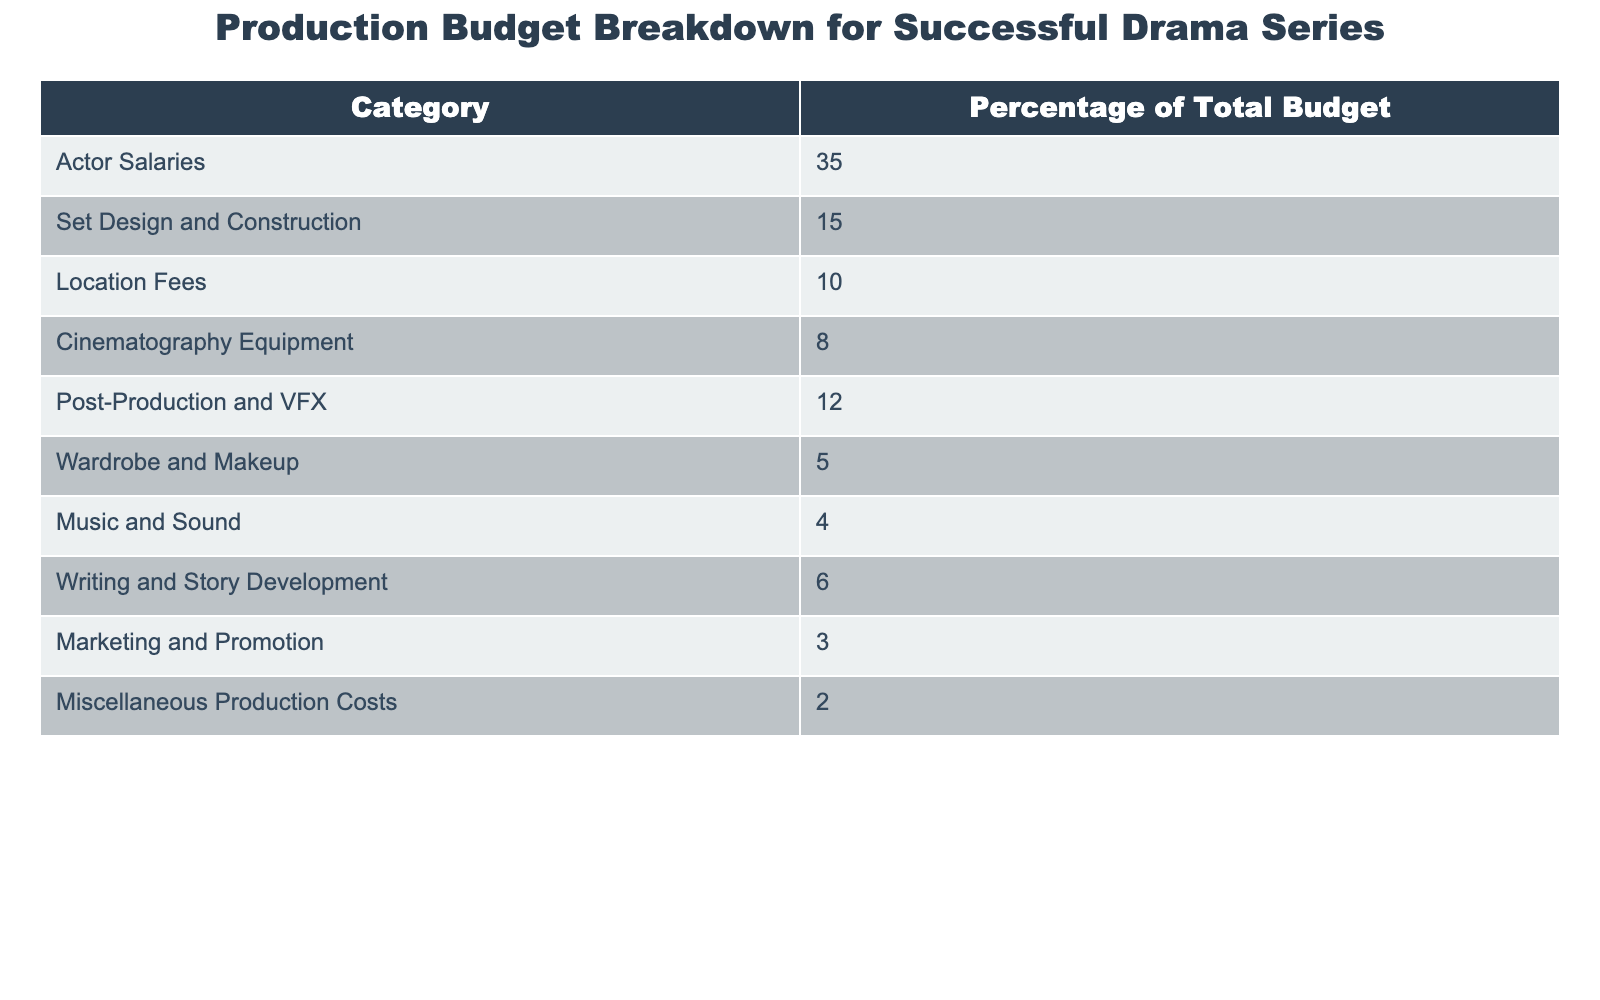What percentage of the total budget is allocated for Actor Salaries? The table shows that Actor Salaries account for 35% of the total budget.
Answer: 35% Which two categories have the highest budget percentages? The table indicates that Actor Salaries (35%) and Set Design and Construction (15%) have the highest percentages.
Answer: Actor Salaries and Set Design and Construction What is the total percentage of the budget allocated for Music and Sound and Wardrobe and Makeup combined? Adding the percentages from the table: Music and Sound (4%) + Wardrobe and Makeup (5%) equals 9%.
Answer: 9% Is the percentage allocated for Marketing and Promotion greater than that for Miscellaneous Production Costs? The table shows that Marketing and Promotion (3%) is greater than Miscellaneous Production Costs (2%).
Answer: Yes What is the difference in budget percentage between Set Design and Construction and Cinematography Equipment? Set Design and Construction is 15%, and Cinematography Equipment is 8%. The difference is 15% - 8% = 7%.
Answer: 7% If the total production budget is $1 million, how much is allocated for Post-Production and VFX? Post-Production and VFX is 12% of the total budget. Calculating this, 12% of $1 million is $120,000.
Answer: $120,000 What percentage of the budget is dedicated to categories other than the top three most funded ones? The top three categories are Actor Salaries (35%), Set Design and Construction (15%), and Location Fees (10%), totaling 60%. Thus, the percentage for others is 100% - 60% = 40%.
Answer: 40% If you combine the budget percentages of Writing and Story Development with Music and Sound, what do you get? Writing and Story Development is 6%, and Music and Sound is 4%. Adding these gives 6% + 4% = 10%.
Answer: 10% What is the percentage of the budget allocated for actor salaries compared to that of Wardrobe and Makeup? Actor Salaries are 35% and Wardrobe and Makeup are 5%. The comparison shows that Actor Salaries are significantly greater; specifically, 35% - 5% = 30%.
Answer: 30% Can you confirm whether Location Fees represent less than 15% of the total budget? The table states that Location Fees are exactly 10%, which is less than 15%.
Answer: Yes 